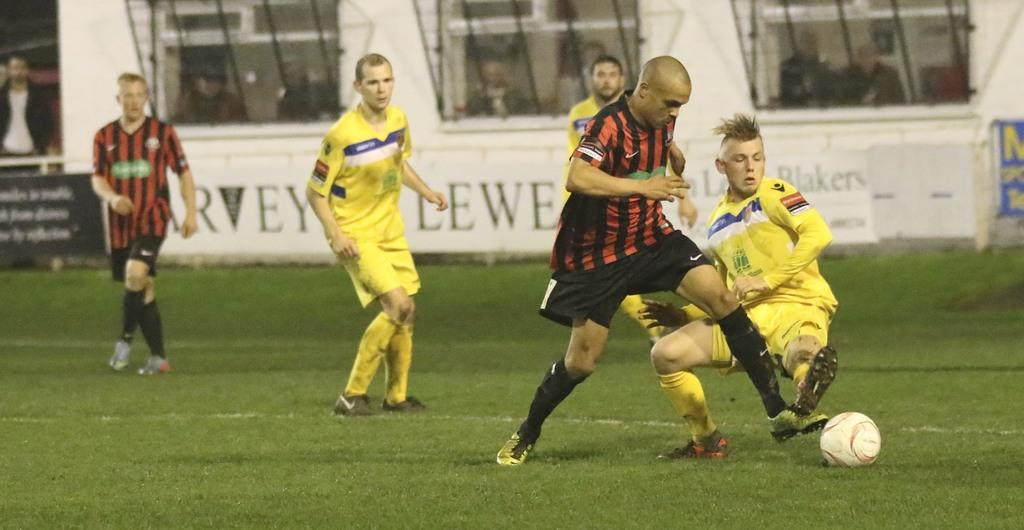Provide a one-sentence caption for the provided image. Soccer players play a game on a field with a banner with the text Blakers. 